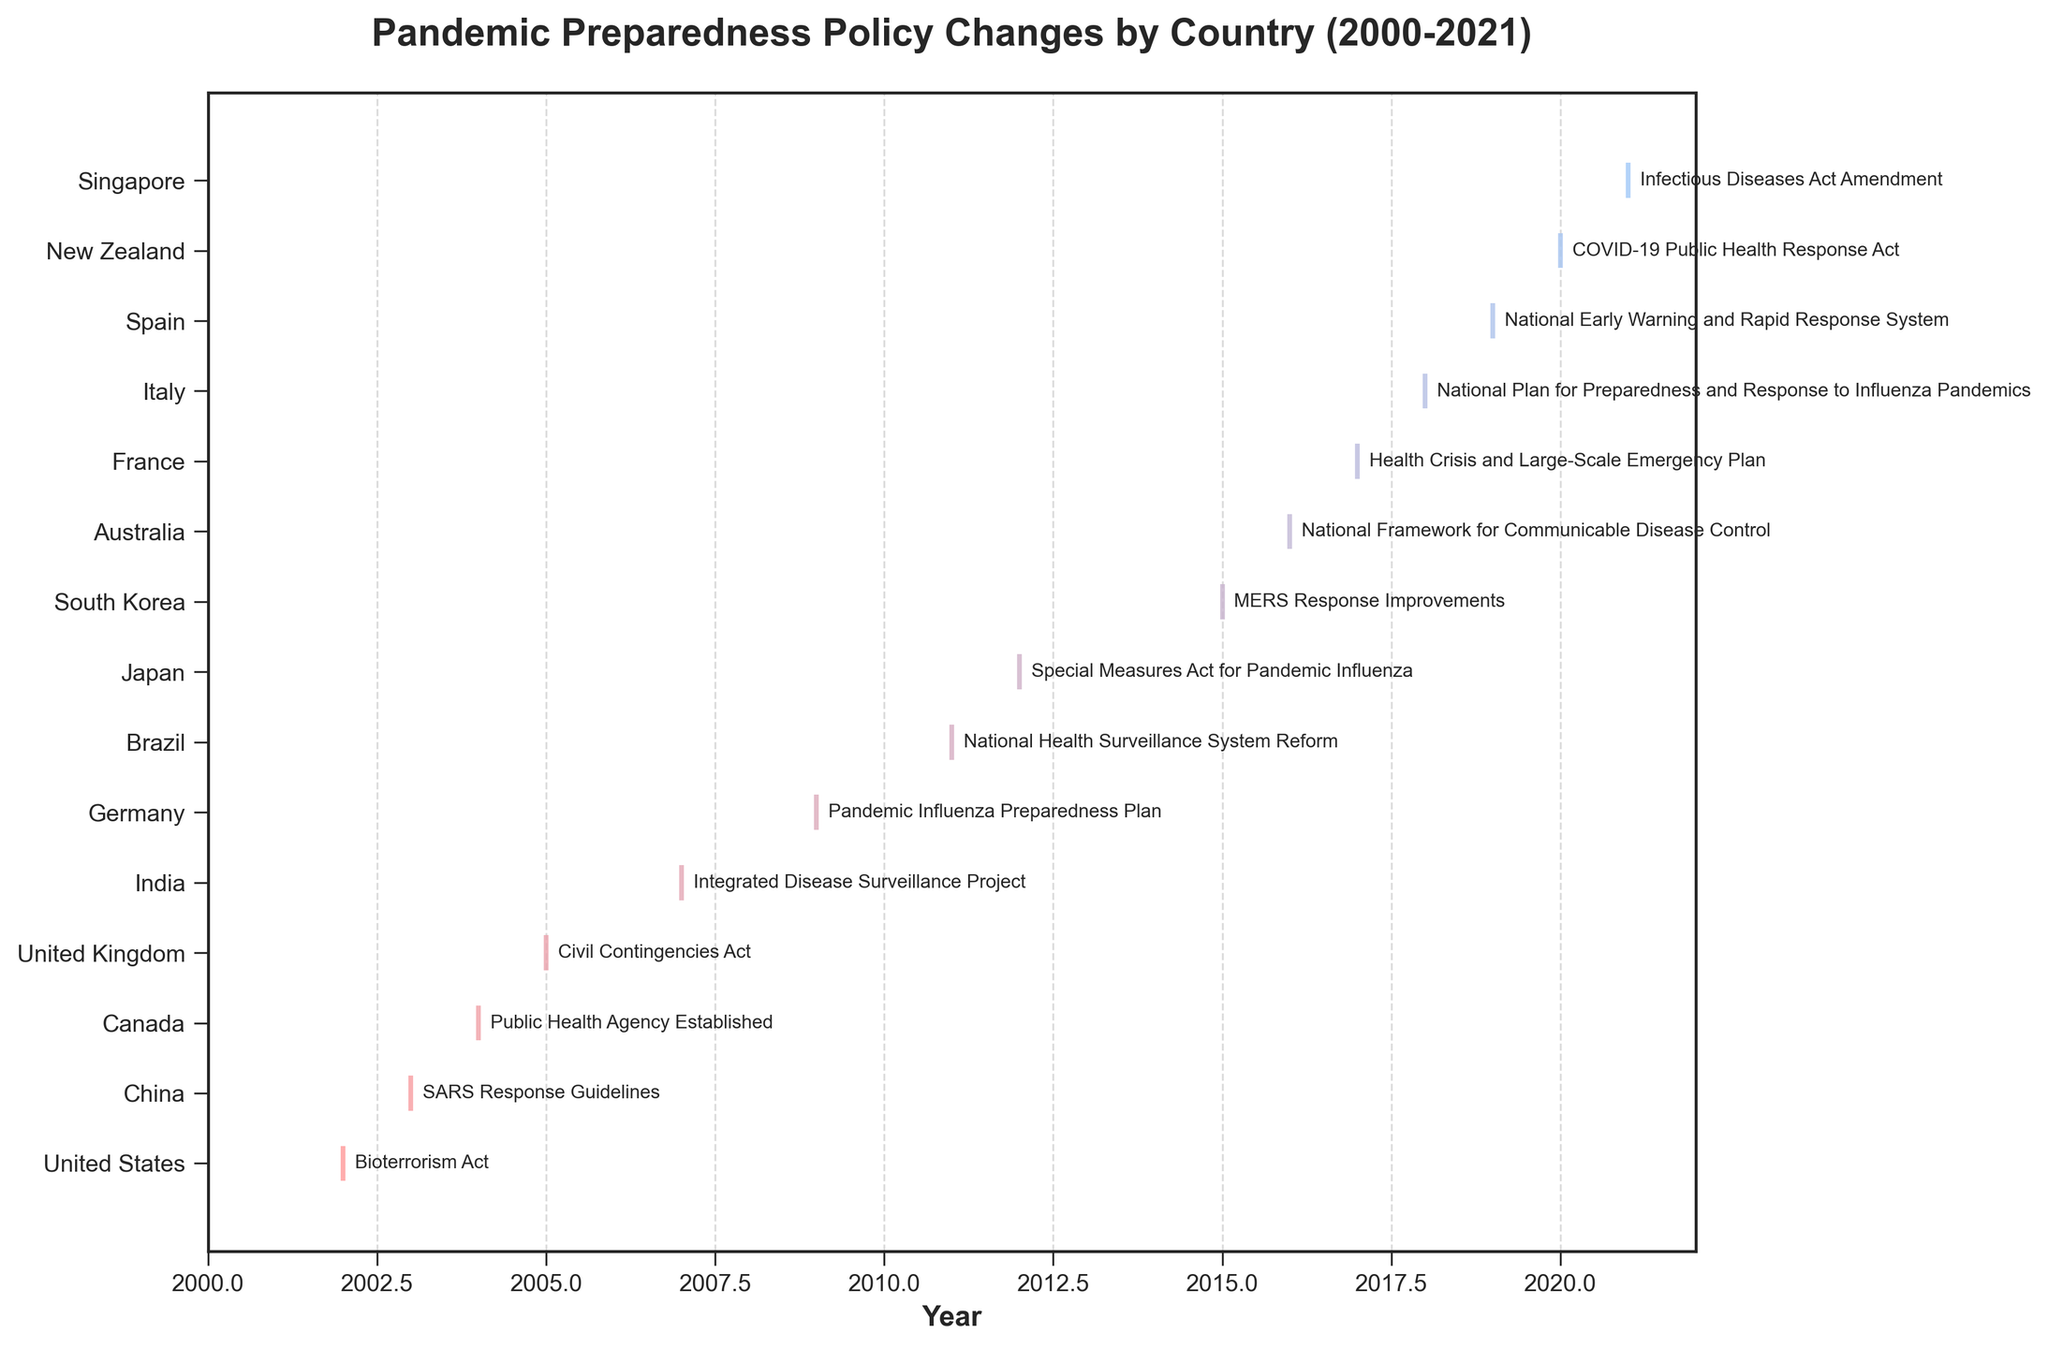How many policy changes are shown in the figure? Count the total number of events marked on the plot. Each event line corresponds to a policy change.
Answer: 15 Which countries have instituted pandemic preparedness policies in consecutive years? Check the plot for countries that have multiple events spaced one year apart. Italy and Spain have policies in 2018 and 2019, respectively.
Answer: Italy and Spain Which country made the first policy change related to pandemic preparedness? Find the earliest year on the x-axis and see which country has a policy change corresponding to that year. The United States made a policy change in 2002.
Answer: United States What is the average year of policy change for pandemic preparedness measures? Sum all the years of policy changes and divide by the total number of events: (2002+2003+2004+2005+2007+2009+2011+2012+2015+2016+2017+2018+2019+2020+2021) / 15 = 2010.6
Answer: 2010.6 Which country had a policy change after the MERS outbreak of 2015? Identify the events that occur after 2015 on the x-axis and note the corresponding countries. Events from 2016 onward are from Australia, France, Italy, Spain, New Zealand, and Singapore.
Answer: Australia, France, Italy, Spain, New Zealand, Singapore How many countries implemented new policies in or after 2010? Count the number of countries that have an event line starting from the year 2010 onwards. Events from 2010 and later are visible for Brazil, Japan, South Korea, Australia, France, Italy, Spain, New Zealand, and Singapore.
Answer: 9 Which country had the most recent policy change, and what was it? Identify the furthest year on the x-axis with a policy change and see which country is associated with it. Singapore made a policy change in 2021.
Answer: Singapore, Infectious Diseases Act Amendment What is the time gap between Canada and Germany's policy changes? Subtract the year of Germany’s policy change from the year of Canada’s: 2009 (Germany) - 2004 (Canada) = 5 years
Answer: 5 years Which year had the highest number of policy changes across all countries? Count the events for each year and determine the year with the most events. No year has more than one policy change in this dataset.
Answer: None (no multiple changes in one year) 